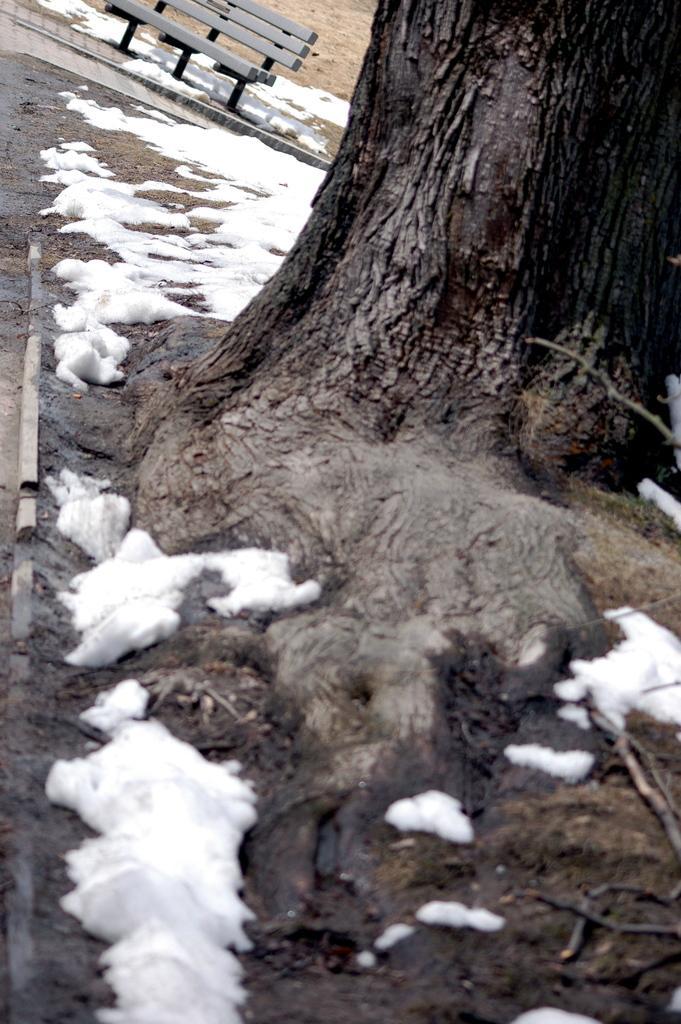How would you summarize this image in a sentence or two? In this picture, we can see snow, tree and behind the tree there is a bench on the path. 